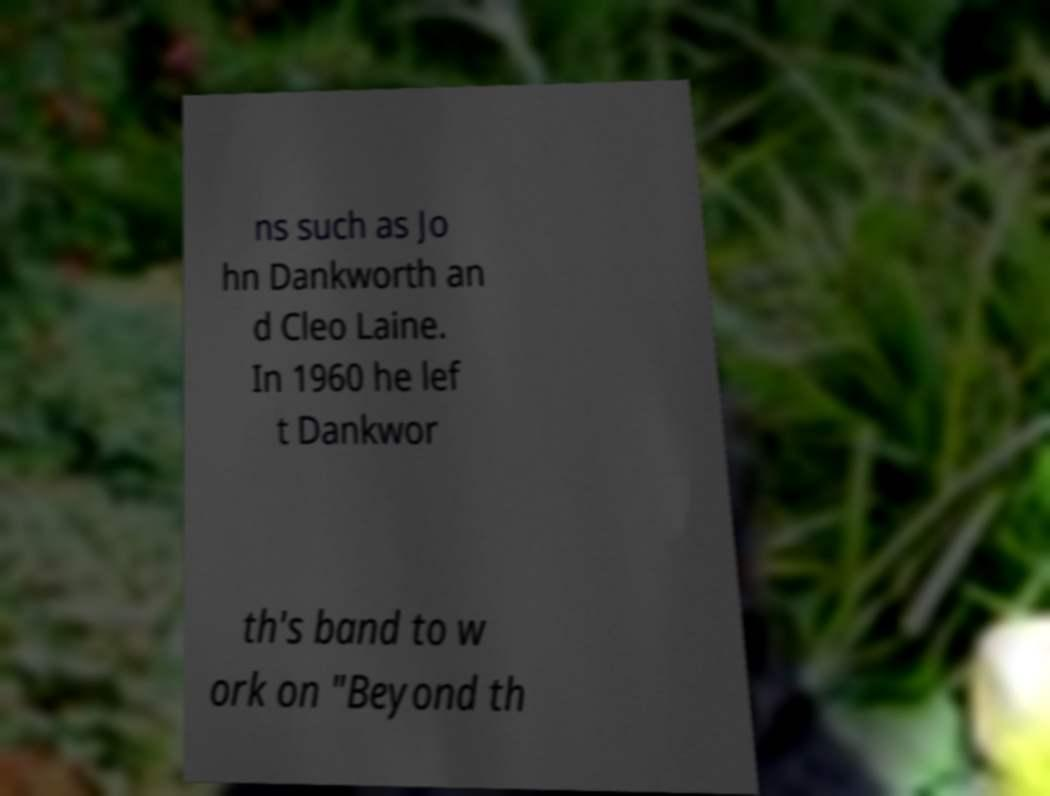Please read and relay the text visible in this image. What does it say? ns such as Jo hn Dankworth an d Cleo Laine. In 1960 he lef t Dankwor th's band to w ork on "Beyond th 